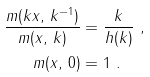Convert formula to latex. <formula><loc_0><loc_0><loc_500><loc_500>\frac { m ( k x , \, k ^ { - 1 } ) } { m ( x , \, k ) } & = \frac { k } { h ( k ) } \ , \\ m ( x , \, 0 ) & = 1 \ .</formula> 